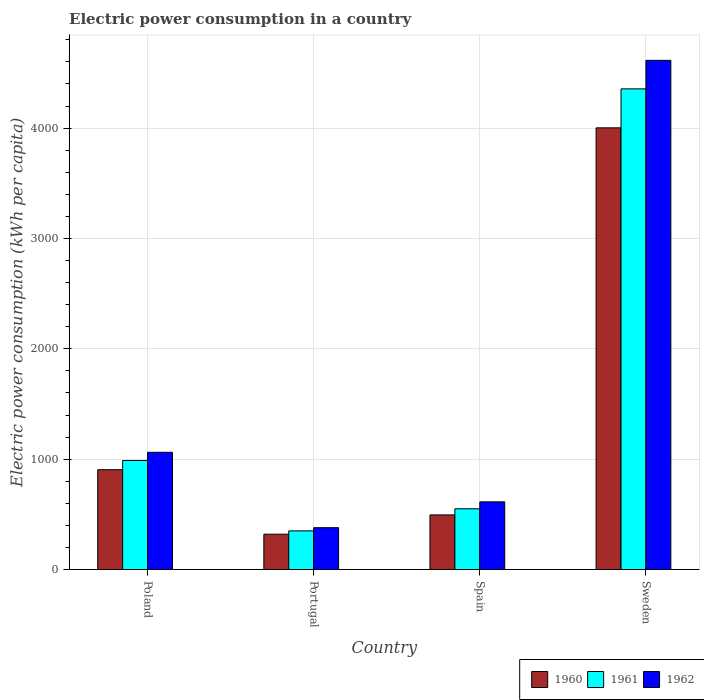How many different coloured bars are there?
Offer a very short reply. 3. Are the number of bars per tick equal to the number of legend labels?
Ensure brevity in your answer.  Yes. Are the number of bars on each tick of the X-axis equal?
Provide a succinct answer. Yes. What is the electric power consumption in in 1960 in Spain?
Provide a short and direct response. 494.8. Across all countries, what is the maximum electric power consumption in in 1960?
Your response must be concise. 4002.32. Across all countries, what is the minimum electric power consumption in in 1962?
Provide a succinct answer. 379.14. What is the total electric power consumption in in 1962 in the graph?
Make the answer very short. 6668.54. What is the difference between the electric power consumption in in 1960 in Portugal and that in Spain?
Ensure brevity in your answer.  -174.62. What is the difference between the electric power consumption in in 1960 in Spain and the electric power consumption in in 1961 in Portugal?
Offer a very short reply. 144.6. What is the average electric power consumption in in 1960 per country?
Your answer should be very brief. 1430.46. What is the difference between the electric power consumption in of/in 1960 and electric power consumption in of/in 1961 in Sweden?
Make the answer very short. -353.13. What is the ratio of the electric power consumption in in 1962 in Portugal to that in Sweden?
Give a very brief answer. 0.08. Is the electric power consumption in in 1961 in Portugal less than that in Sweden?
Your answer should be compact. Yes. Is the difference between the electric power consumption in in 1960 in Portugal and Spain greater than the difference between the electric power consumption in in 1961 in Portugal and Spain?
Provide a succinct answer. Yes. What is the difference between the highest and the second highest electric power consumption in in 1961?
Offer a very short reply. -3805.02. What is the difference between the highest and the lowest electric power consumption in in 1961?
Offer a terse response. 4005.26. What does the 2nd bar from the left in Poland represents?
Offer a terse response. 1961. How many bars are there?
Your answer should be compact. 12. Does the graph contain any zero values?
Your response must be concise. No. Where does the legend appear in the graph?
Give a very brief answer. Bottom right. How many legend labels are there?
Your answer should be compact. 3. How are the legend labels stacked?
Give a very brief answer. Horizontal. What is the title of the graph?
Give a very brief answer. Electric power consumption in a country. Does "1991" appear as one of the legend labels in the graph?
Provide a succinct answer. No. What is the label or title of the X-axis?
Keep it short and to the point. Country. What is the label or title of the Y-axis?
Provide a succinct answer. Electric power consumption (kWh per capita). What is the Electric power consumption (kWh per capita) in 1960 in Poland?
Your response must be concise. 904.57. What is the Electric power consumption (kWh per capita) of 1961 in Poland?
Your answer should be very brief. 987.92. What is the Electric power consumption (kWh per capita) of 1962 in Poland?
Your response must be concise. 1062.18. What is the Electric power consumption (kWh per capita) in 1960 in Portugal?
Provide a succinct answer. 320.17. What is the Electric power consumption (kWh per capita) in 1961 in Portugal?
Offer a terse response. 350.19. What is the Electric power consumption (kWh per capita) in 1962 in Portugal?
Provide a succinct answer. 379.14. What is the Electric power consumption (kWh per capita) of 1960 in Spain?
Offer a terse response. 494.8. What is the Electric power consumption (kWh per capita) in 1961 in Spain?
Offer a terse response. 550.44. What is the Electric power consumption (kWh per capita) in 1962 in Spain?
Offer a terse response. 613.25. What is the Electric power consumption (kWh per capita) in 1960 in Sweden?
Offer a terse response. 4002.32. What is the Electric power consumption (kWh per capita) of 1961 in Sweden?
Make the answer very short. 4355.45. What is the Electric power consumption (kWh per capita) of 1962 in Sweden?
Your answer should be compact. 4613.98. Across all countries, what is the maximum Electric power consumption (kWh per capita) of 1960?
Offer a very short reply. 4002.32. Across all countries, what is the maximum Electric power consumption (kWh per capita) in 1961?
Your response must be concise. 4355.45. Across all countries, what is the maximum Electric power consumption (kWh per capita) of 1962?
Keep it short and to the point. 4613.98. Across all countries, what is the minimum Electric power consumption (kWh per capita) in 1960?
Give a very brief answer. 320.17. Across all countries, what is the minimum Electric power consumption (kWh per capita) in 1961?
Provide a short and direct response. 350.19. Across all countries, what is the minimum Electric power consumption (kWh per capita) of 1962?
Ensure brevity in your answer.  379.14. What is the total Electric power consumption (kWh per capita) of 1960 in the graph?
Give a very brief answer. 5721.85. What is the total Electric power consumption (kWh per capita) in 1961 in the graph?
Provide a short and direct response. 6244. What is the total Electric power consumption (kWh per capita) of 1962 in the graph?
Your answer should be very brief. 6668.54. What is the difference between the Electric power consumption (kWh per capita) of 1960 in Poland and that in Portugal?
Offer a very short reply. 584.39. What is the difference between the Electric power consumption (kWh per capita) in 1961 in Poland and that in Portugal?
Keep it short and to the point. 637.72. What is the difference between the Electric power consumption (kWh per capita) in 1962 in Poland and that in Portugal?
Make the answer very short. 683.03. What is the difference between the Electric power consumption (kWh per capita) of 1960 in Poland and that in Spain?
Keep it short and to the point. 409.77. What is the difference between the Electric power consumption (kWh per capita) in 1961 in Poland and that in Spain?
Provide a short and direct response. 437.48. What is the difference between the Electric power consumption (kWh per capita) of 1962 in Poland and that in Spain?
Provide a succinct answer. 448.93. What is the difference between the Electric power consumption (kWh per capita) of 1960 in Poland and that in Sweden?
Your answer should be very brief. -3097.76. What is the difference between the Electric power consumption (kWh per capita) in 1961 in Poland and that in Sweden?
Your answer should be compact. -3367.53. What is the difference between the Electric power consumption (kWh per capita) of 1962 in Poland and that in Sweden?
Your response must be concise. -3551.8. What is the difference between the Electric power consumption (kWh per capita) in 1960 in Portugal and that in Spain?
Give a very brief answer. -174.62. What is the difference between the Electric power consumption (kWh per capita) of 1961 in Portugal and that in Spain?
Make the answer very short. -200.24. What is the difference between the Electric power consumption (kWh per capita) in 1962 in Portugal and that in Spain?
Ensure brevity in your answer.  -234.11. What is the difference between the Electric power consumption (kWh per capita) in 1960 in Portugal and that in Sweden?
Your response must be concise. -3682.15. What is the difference between the Electric power consumption (kWh per capita) of 1961 in Portugal and that in Sweden?
Offer a very short reply. -4005.26. What is the difference between the Electric power consumption (kWh per capita) of 1962 in Portugal and that in Sweden?
Your response must be concise. -4234.84. What is the difference between the Electric power consumption (kWh per capita) of 1960 in Spain and that in Sweden?
Offer a terse response. -3507.53. What is the difference between the Electric power consumption (kWh per capita) in 1961 in Spain and that in Sweden?
Offer a terse response. -3805.02. What is the difference between the Electric power consumption (kWh per capita) in 1962 in Spain and that in Sweden?
Your answer should be compact. -4000.73. What is the difference between the Electric power consumption (kWh per capita) of 1960 in Poland and the Electric power consumption (kWh per capita) of 1961 in Portugal?
Make the answer very short. 554.37. What is the difference between the Electric power consumption (kWh per capita) of 1960 in Poland and the Electric power consumption (kWh per capita) of 1962 in Portugal?
Ensure brevity in your answer.  525.42. What is the difference between the Electric power consumption (kWh per capita) of 1961 in Poland and the Electric power consumption (kWh per capita) of 1962 in Portugal?
Make the answer very short. 608.78. What is the difference between the Electric power consumption (kWh per capita) of 1960 in Poland and the Electric power consumption (kWh per capita) of 1961 in Spain?
Your response must be concise. 354.13. What is the difference between the Electric power consumption (kWh per capita) in 1960 in Poland and the Electric power consumption (kWh per capita) in 1962 in Spain?
Provide a short and direct response. 291.32. What is the difference between the Electric power consumption (kWh per capita) of 1961 in Poland and the Electric power consumption (kWh per capita) of 1962 in Spain?
Offer a terse response. 374.67. What is the difference between the Electric power consumption (kWh per capita) in 1960 in Poland and the Electric power consumption (kWh per capita) in 1961 in Sweden?
Provide a short and direct response. -3450.89. What is the difference between the Electric power consumption (kWh per capita) of 1960 in Poland and the Electric power consumption (kWh per capita) of 1962 in Sweden?
Your response must be concise. -3709.41. What is the difference between the Electric power consumption (kWh per capita) in 1961 in Poland and the Electric power consumption (kWh per capita) in 1962 in Sweden?
Your answer should be compact. -3626.06. What is the difference between the Electric power consumption (kWh per capita) in 1960 in Portugal and the Electric power consumption (kWh per capita) in 1961 in Spain?
Keep it short and to the point. -230.26. What is the difference between the Electric power consumption (kWh per capita) of 1960 in Portugal and the Electric power consumption (kWh per capita) of 1962 in Spain?
Ensure brevity in your answer.  -293.07. What is the difference between the Electric power consumption (kWh per capita) of 1961 in Portugal and the Electric power consumption (kWh per capita) of 1962 in Spain?
Provide a short and direct response. -263.05. What is the difference between the Electric power consumption (kWh per capita) in 1960 in Portugal and the Electric power consumption (kWh per capita) in 1961 in Sweden?
Your answer should be compact. -4035.28. What is the difference between the Electric power consumption (kWh per capita) of 1960 in Portugal and the Electric power consumption (kWh per capita) of 1962 in Sweden?
Offer a terse response. -4293.81. What is the difference between the Electric power consumption (kWh per capita) of 1961 in Portugal and the Electric power consumption (kWh per capita) of 1962 in Sweden?
Give a very brief answer. -4263.78. What is the difference between the Electric power consumption (kWh per capita) of 1960 in Spain and the Electric power consumption (kWh per capita) of 1961 in Sweden?
Provide a short and direct response. -3860.66. What is the difference between the Electric power consumption (kWh per capita) in 1960 in Spain and the Electric power consumption (kWh per capita) in 1962 in Sweden?
Make the answer very short. -4119.18. What is the difference between the Electric power consumption (kWh per capita) of 1961 in Spain and the Electric power consumption (kWh per capita) of 1962 in Sweden?
Keep it short and to the point. -4063.54. What is the average Electric power consumption (kWh per capita) in 1960 per country?
Offer a very short reply. 1430.46. What is the average Electric power consumption (kWh per capita) of 1961 per country?
Offer a terse response. 1561. What is the average Electric power consumption (kWh per capita) in 1962 per country?
Your answer should be very brief. 1667.14. What is the difference between the Electric power consumption (kWh per capita) of 1960 and Electric power consumption (kWh per capita) of 1961 in Poland?
Your response must be concise. -83.35. What is the difference between the Electric power consumption (kWh per capita) of 1960 and Electric power consumption (kWh per capita) of 1962 in Poland?
Ensure brevity in your answer.  -157.61. What is the difference between the Electric power consumption (kWh per capita) in 1961 and Electric power consumption (kWh per capita) in 1962 in Poland?
Keep it short and to the point. -74.26. What is the difference between the Electric power consumption (kWh per capita) in 1960 and Electric power consumption (kWh per capita) in 1961 in Portugal?
Give a very brief answer. -30.02. What is the difference between the Electric power consumption (kWh per capita) in 1960 and Electric power consumption (kWh per capita) in 1962 in Portugal?
Your answer should be very brief. -58.97. What is the difference between the Electric power consumption (kWh per capita) of 1961 and Electric power consumption (kWh per capita) of 1962 in Portugal?
Your answer should be compact. -28.95. What is the difference between the Electric power consumption (kWh per capita) in 1960 and Electric power consumption (kWh per capita) in 1961 in Spain?
Ensure brevity in your answer.  -55.64. What is the difference between the Electric power consumption (kWh per capita) of 1960 and Electric power consumption (kWh per capita) of 1962 in Spain?
Provide a short and direct response. -118.45. What is the difference between the Electric power consumption (kWh per capita) of 1961 and Electric power consumption (kWh per capita) of 1962 in Spain?
Your response must be concise. -62.81. What is the difference between the Electric power consumption (kWh per capita) of 1960 and Electric power consumption (kWh per capita) of 1961 in Sweden?
Keep it short and to the point. -353.13. What is the difference between the Electric power consumption (kWh per capita) in 1960 and Electric power consumption (kWh per capita) in 1962 in Sweden?
Your answer should be compact. -611.66. What is the difference between the Electric power consumption (kWh per capita) in 1961 and Electric power consumption (kWh per capita) in 1962 in Sweden?
Provide a short and direct response. -258.52. What is the ratio of the Electric power consumption (kWh per capita) of 1960 in Poland to that in Portugal?
Give a very brief answer. 2.83. What is the ratio of the Electric power consumption (kWh per capita) of 1961 in Poland to that in Portugal?
Offer a terse response. 2.82. What is the ratio of the Electric power consumption (kWh per capita) in 1962 in Poland to that in Portugal?
Keep it short and to the point. 2.8. What is the ratio of the Electric power consumption (kWh per capita) of 1960 in Poland to that in Spain?
Keep it short and to the point. 1.83. What is the ratio of the Electric power consumption (kWh per capita) in 1961 in Poland to that in Spain?
Ensure brevity in your answer.  1.79. What is the ratio of the Electric power consumption (kWh per capita) of 1962 in Poland to that in Spain?
Provide a succinct answer. 1.73. What is the ratio of the Electric power consumption (kWh per capita) of 1960 in Poland to that in Sweden?
Provide a short and direct response. 0.23. What is the ratio of the Electric power consumption (kWh per capita) of 1961 in Poland to that in Sweden?
Offer a very short reply. 0.23. What is the ratio of the Electric power consumption (kWh per capita) in 1962 in Poland to that in Sweden?
Your response must be concise. 0.23. What is the ratio of the Electric power consumption (kWh per capita) in 1960 in Portugal to that in Spain?
Keep it short and to the point. 0.65. What is the ratio of the Electric power consumption (kWh per capita) in 1961 in Portugal to that in Spain?
Provide a succinct answer. 0.64. What is the ratio of the Electric power consumption (kWh per capita) in 1962 in Portugal to that in Spain?
Your answer should be very brief. 0.62. What is the ratio of the Electric power consumption (kWh per capita) of 1960 in Portugal to that in Sweden?
Your answer should be compact. 0.08. What is the ratio of the Electric power consumption (kWh per capita) of 1961 in Portugal to that in Sweden?
Your answer should be very brief. 0.08. What is the ratio of the Electric power consumption (kWh per capita) of 1962 in Portugal to that in Sweden?
Keep it short and to the point. 0.08. What is the ratio of the Electric power consumption (kWh per capita) in 1960 in Spain to that in Sweden?
Your answer should be compact. 0.12. What is the ratio of the Electric power consumption (kWh per capita) in 1961 in Spain to that in Sweden?
Give a very brief answer. 0.13. What is the ratio of the Electric power consumption (kWh per capita) in 1962 in Spain to that in Sweden?
Your response must be concise. 0.13. What is the difference between the highest and the second highest Electric power consumption (kWh per capita) in 1960?
Your response must be concise. 3097.76. What is the difference between the highest and the second highest Electric power consumption (kWh per capita) in 1961?
Give a very brief answer. 3367.53. What is the difference between the highest and the second highest Electric power consumption (kWh per capita) of 1962?
Your response must be concise. 3551.8. What is the difference between the highest and the lowest Electric power consumption (kWh per capita) of 1960?
Provide a short and direct response. 3682.15. What is the difference between the highest and the lowest Electric power consumption (kWh per capita) of 1961?
Provide a short and direct response. 4005.26. What is the difference between the highest and the lowest Electric power consumption (kWh per capita) in 1962?
Give a very brief answer. 4234.84. 